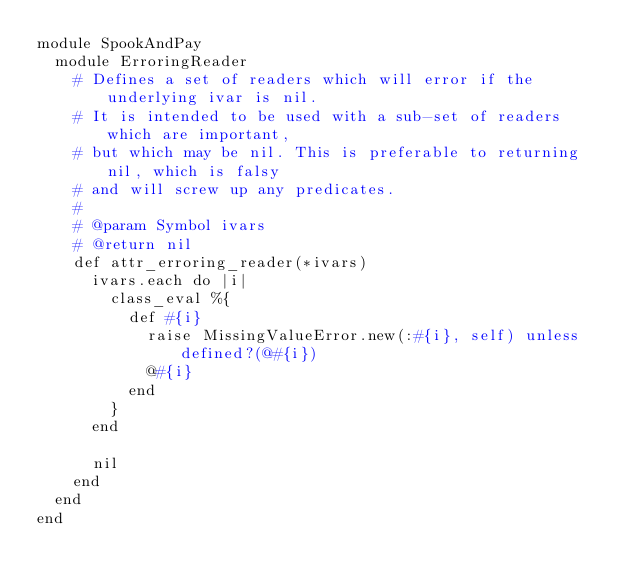Convert code to text. <code><loc_0><loc_0><loc_500><loc_500><_Ruby_>module SpookAndPay
  module ErroringReader
    # Defines a set of readers which will error if the underlying ivar is nil.
    # It is intended to be used with a sub-set of readers which are important,
    # but which may be nil. This is preferable to returning nil, which is falsy
    # and will screw up any predicates.
    #
    # @param Symbol ivars
    # @return nil
    def attr_erroring_reader(*ivars)
      ivars.each do |i|
        class_eval %{
          def #{i}
            raise MissingValueError.new(:#{i}, self) unless defined?(@#{i})
            @#{i}
          end
        }
      end

      nil
    end
  end
end
</code> 